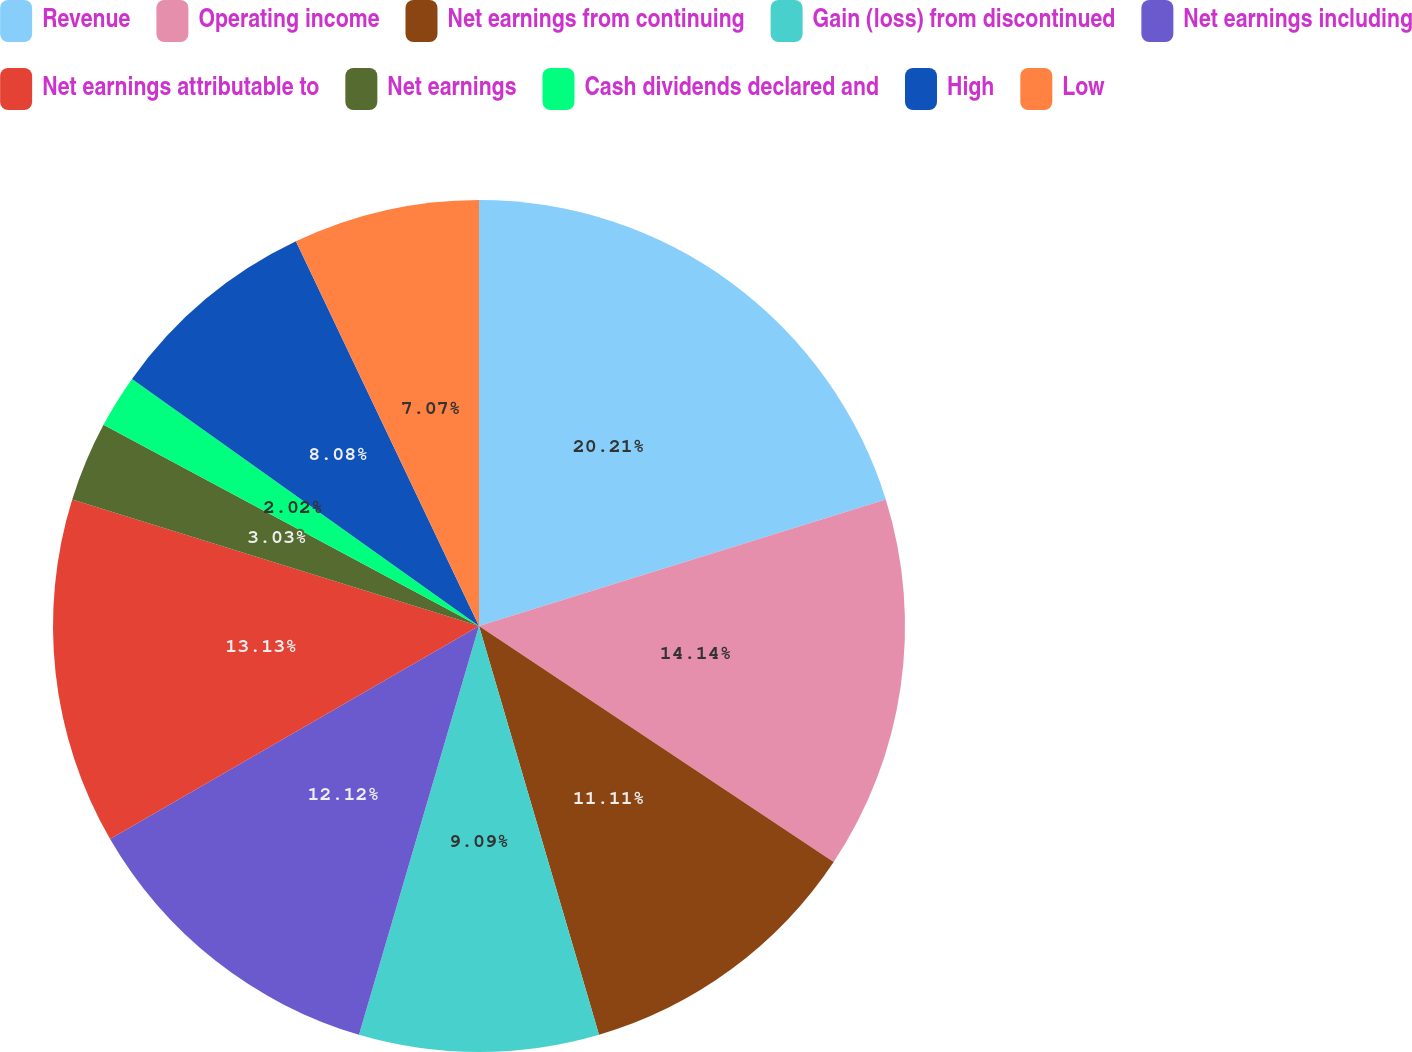Convert chart. <chart><loc_0><loc_0><loc_500><loc_500><pie_chart><fcel>Revenue<fcel>Operating income<fcel>Net earnings from continuing<fcel>Gain (loss) from discontinued<fcel>Net earnings including<fcel>Net earnings attributable to<fcel>Net earnings<fcel>Cash dividends declared and<fcel>High<fcel>Low<nl><fcel>20.2%<fcel>14.14%<fcel>11.11%<fcel>9.09%<fcel>12.12%<fcel>13.13%<fcel>3.03%<fcel>2.02%<fcel>8.08%<fcel>7.07%<nl></chart> 